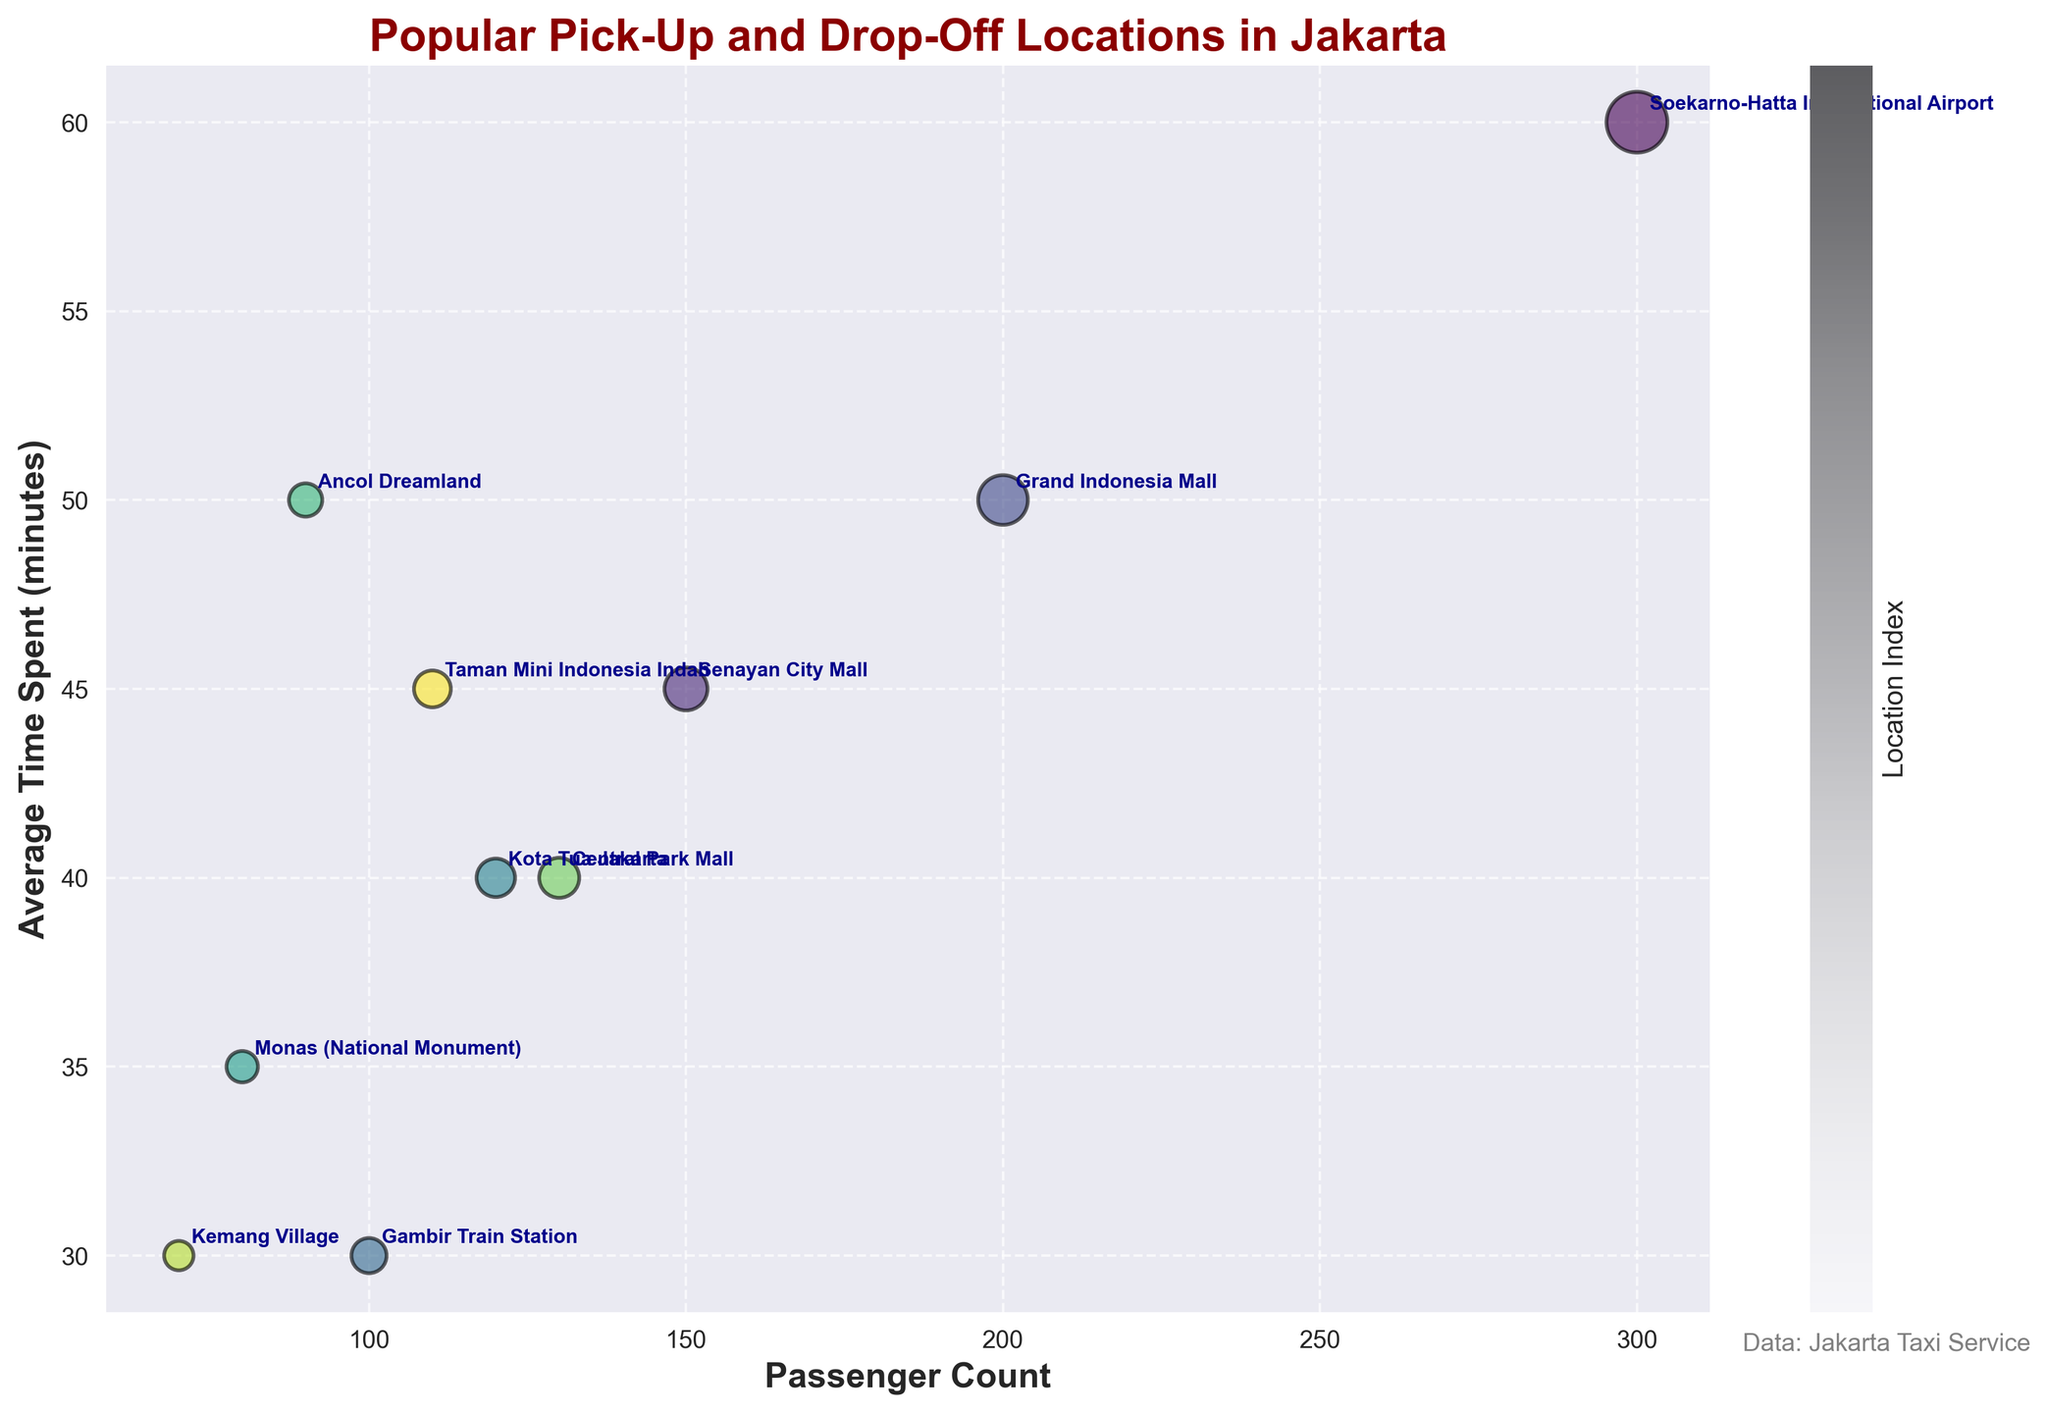What is the title of the figure? The title of the figure is usually placed at the top and is the largest text on the plot.
Answer: Popular Pick-Up and Drop-Off Locations in Jakarta How many pick-up and drop-off locations are displayed in the figure? By counting the number of unique locations annotated on the plot, we can determine the total number of locations displayed.
Answer: 10 Which location has the highest passenger count? Look for the largest bubble on the x-axis to find the location with the highest passenger count.
Answer: Soekarno-Hatta International Airport What is the average time spent at Central Park Mall? Locate the Central Park Mall label on the plot and note the corresponding y-axis value for the average time spent.
Answer: 40 minutes Which location has a higher average time spent, Senayan City Mall or Grand Indonesia Mall? Compare the y-axis values for Senayan City Mall and Grand Indonesia Mall to determine which has the higher average time spent.
Answer: Grand Indonesia Mall What's the total passenger count for locations with average time spent above 45 minutes? Identify locations with average time spent values above 45 minutes and sum their passenger counts.
Answer: Soekarno-Hatta International Airport (300) + Senayan City Mall (150) + Grand Indonesia Mall (200) + Ancol Dreamland (90) = 740 What is the difference in average time spent between Monas (National Monument) and Gambir Train Station? Subtract the average time spent at Gambir Train Station from the average time spent at Monas (National Monument).
Answer: 35 - 30 = 5 minutes Which two locations have nearly identical average time spent? Identify pairs of locations with y-axis values that are very close to each other.
Answer: Central Park Mall and Kota Tua Jakarta (both 40 minutes) How do the sizes of the bubbles relate to the passenger count? Assess the pattern or trend in the plot to determine the relationship between bubble sizes and passenger counts.
Answer: Larger bubbles indicate higher passenger counts Which location has the smallest combination of passenger count and average time spent? Find the smallest bubble located towards the lower-left corner of the plot, indicating the lowest values for both variables.
Answer: Kemang Village 